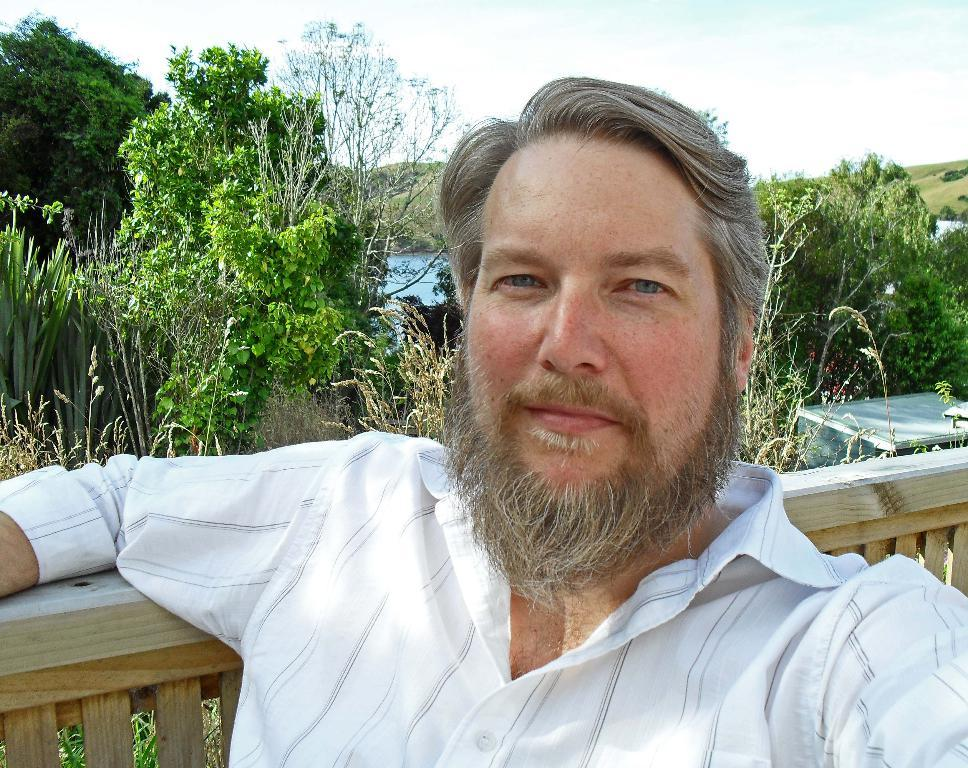What is the person in the image wearing? The person in the image is wearing a white shirt. What type of fencing is visible behind the person? There is a wooden fencing behind the person. What can be seen in the background of the image? Trees and water are visible in the background of the image. What type of agreement is being discussed in the image? There is no indication of an agreement being discussed in the image. 